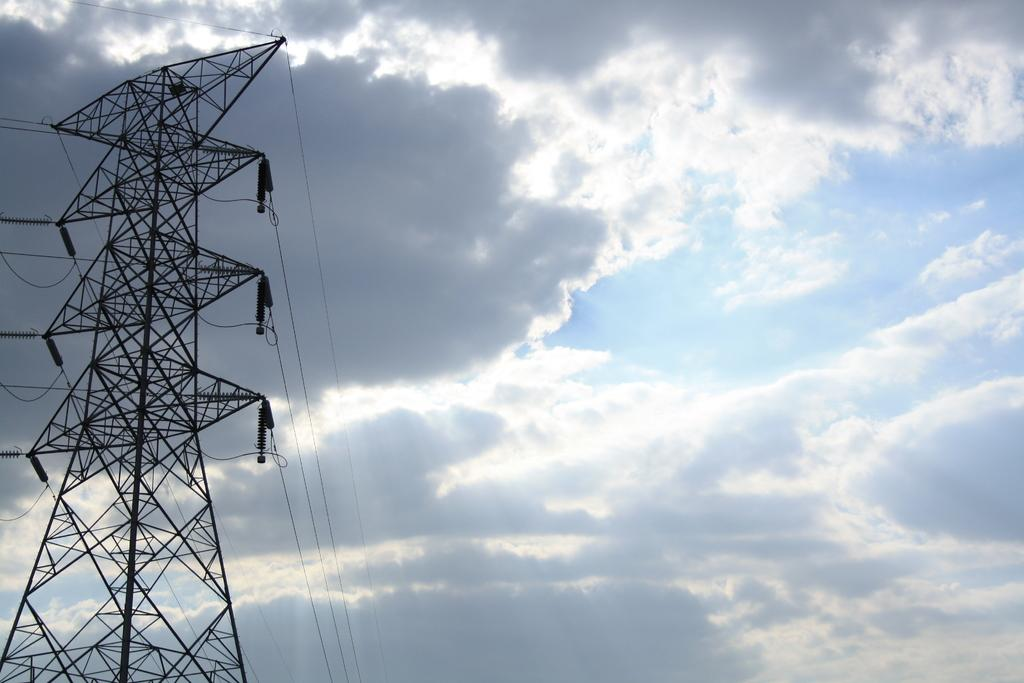What is the main structure visible in the picture? There is a transmission tower in the picture. How would you describe the sky in the image? The sky is blue and cloudy. What type of stew is being prepared near the transmission tower in the image? There is no stew or any cooking activity present in the image; it only features a transmission tower and a blue, cloudy sky. 